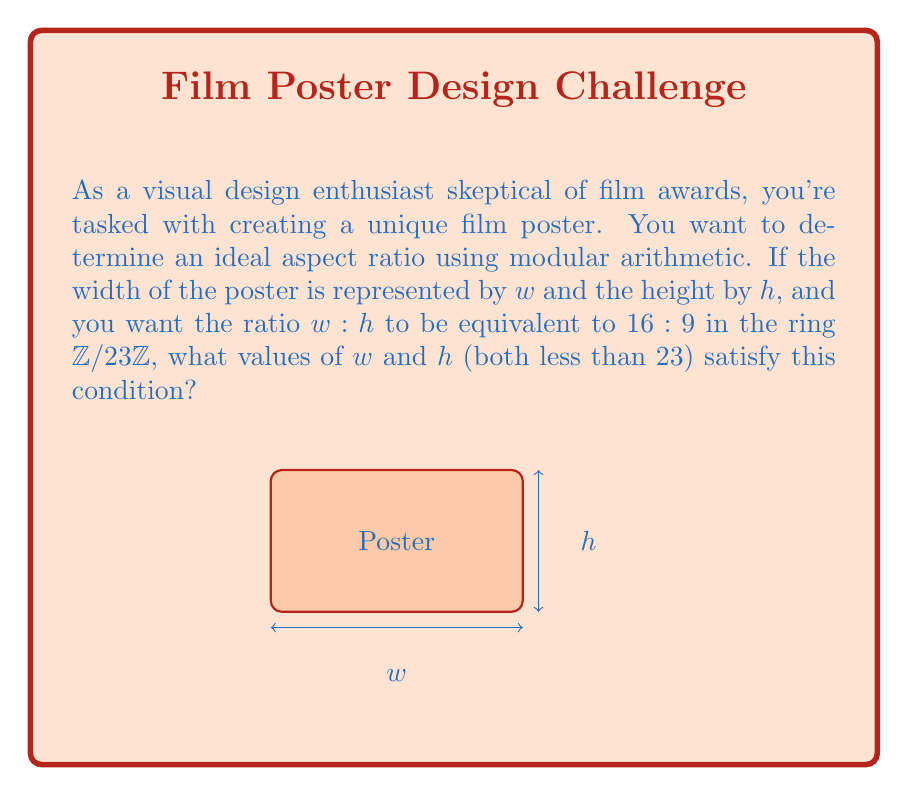Can you solve this math problem? Let's approach this step-by-step:

1) In the ring $\mathbb{Z}/23\mathbb{Z}$, we need to find $w$ and $h$ such that:

   $16h \equiv 9w \pmod{23}$

2) We can rewrite this as:

   $16h - 9w \equiv 0 \pmod{23}$

3) In $\mathbb{Z}/23\mathbb{Z}$, multiplicative inverses exist for all non-zero elements. The multiplicative inverse of 16 is 13 because $16 \cdot 13 \equiv 1 \pmod{23}$.

4) Multiplying both sides by 13:

   $13(16h - 9w) \equiv 0 \pmod{23}$
   $208h - 117w \equiv 0 \pmod{23}$
   $h - 3w \equiv 0 \pmod{23}$

5) This means $h \equiv 3w \pmod{23}$

6) We need to find values of $w$ and $h$ less than 23 that satisfy this condition. Let's try some values:

   If $w = 1$, then $h \equiv 3 \pmod{23}$
   If $w = 2$, then $h \equiv 6 \pmod{23}$
   If $w = 3$, then $h \equiv 9 \pmod{23}$
   If $w = 4$, then $h \equiv 12 \pmod{23}$
   If $w = 5$, then $h \equiv 15 \pmod{23}$
   If $w = 6$, then $h \equiv 18 \pmod{23}$
   If $w = 7$, then $h \equiv 21 \pmod{23}$

7) All of these pairs satisfy the condition. The pair $(16, 9)$ also works, as it directly represents the original ratio.
Answer: $(w, h) \in \{(1, 3), (2, 6), (3, 9), (4, 12), (5, 15), (6, 18), (7, 21), (16, 9)\}$ 